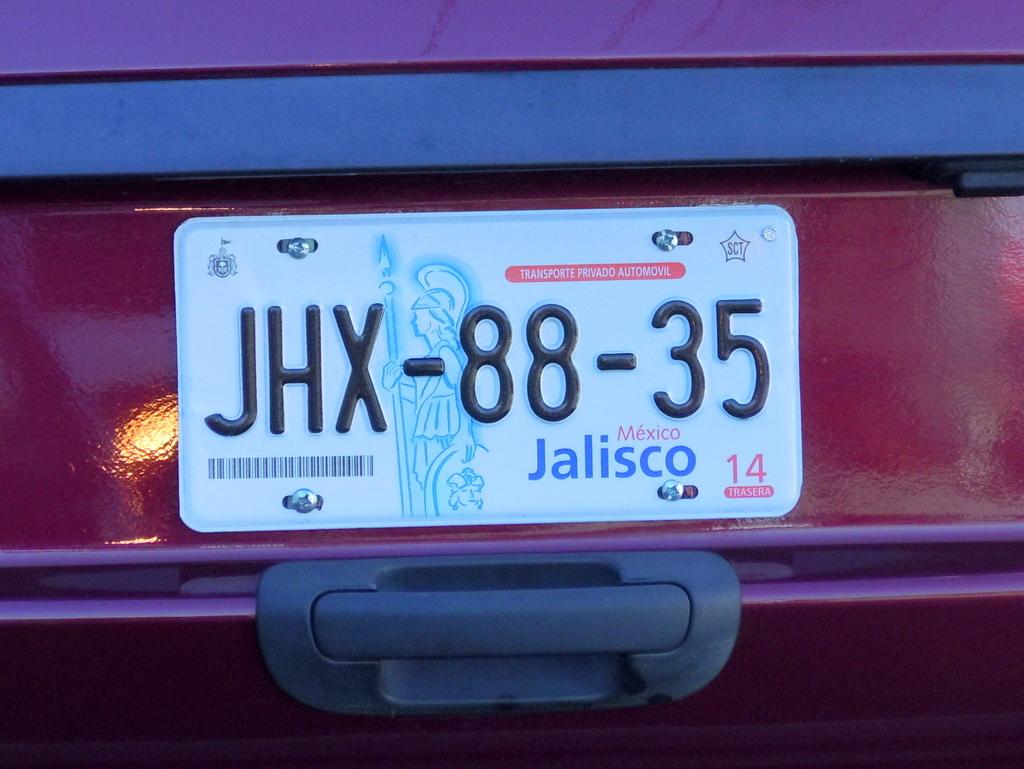What are the three letter of the license plate number?
Your response must be concise. Jhx. 